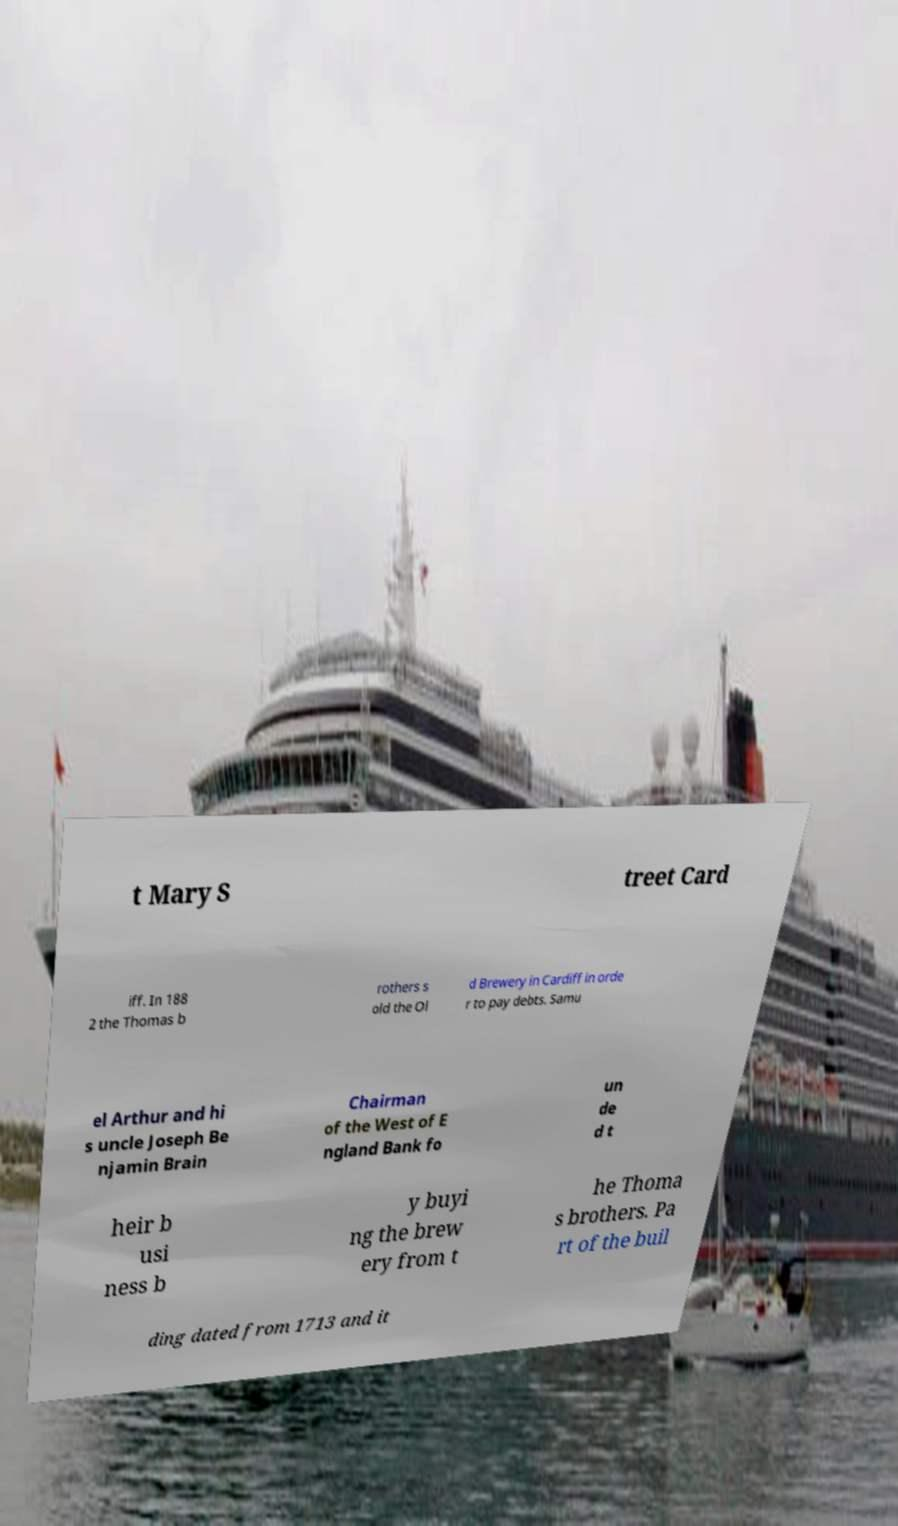What messages or text are displayed in this image? I need them in a readable, typed format. t Mary S treet Card iff. In 188 2 the Thomas b rothers s old the Ol d Brewery in Cardiff in orde r to pay debts. Samu el Arthur and hi s uncle Joseph Be njamin Brain Chairman of the West of E ngland Bank fo un de d t heir b usi ness b y buyi ng the brew ery from t he Thoma s brothers. Pa rt of the buil ding dated from 1713 and it 